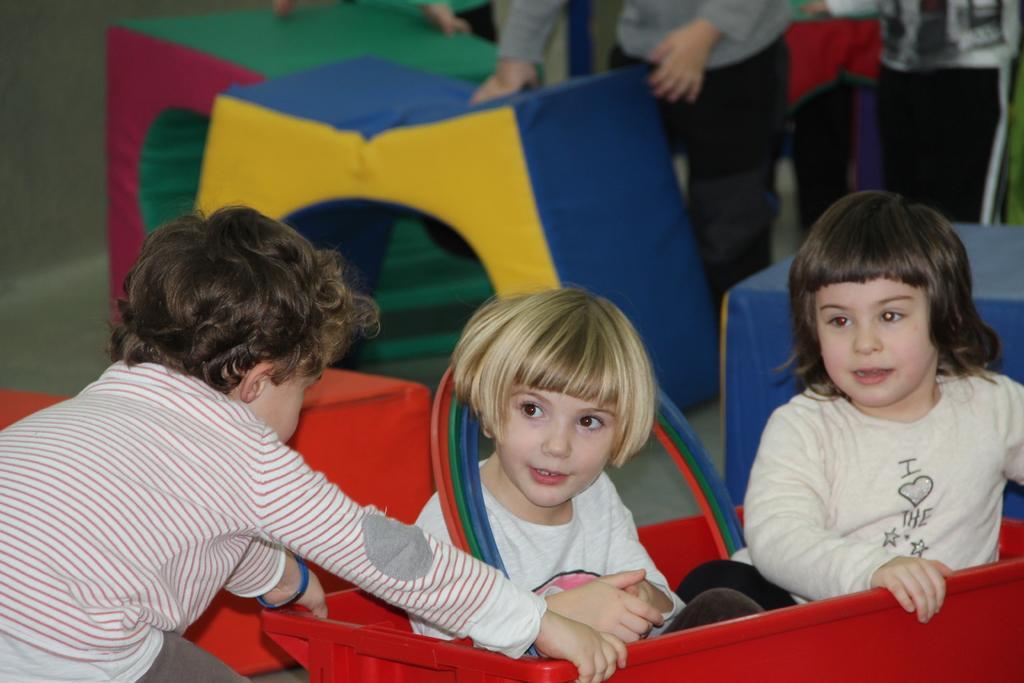Please provide a concise description of this image. In this image there is a girl sitting in the red color box. Beside her there is another girl. On the left side there is a boy who is holding the box. In the background there are few people who are holding the tents which are of different colors. 